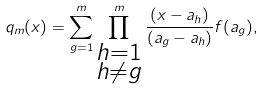<formula> <loc_0><loc_0><loc_500><loc_500>q _ { m } ( x ) = \sum _ { g = 1 } ^ { m } \prod ^ { m } _ { \substack { h = 1 \\ h \neq g } } \frac { ( x - a _ { h } ) } { ( a _ { g } - a _ { h } ) } f ( a _ { g } ) ,</formula> 